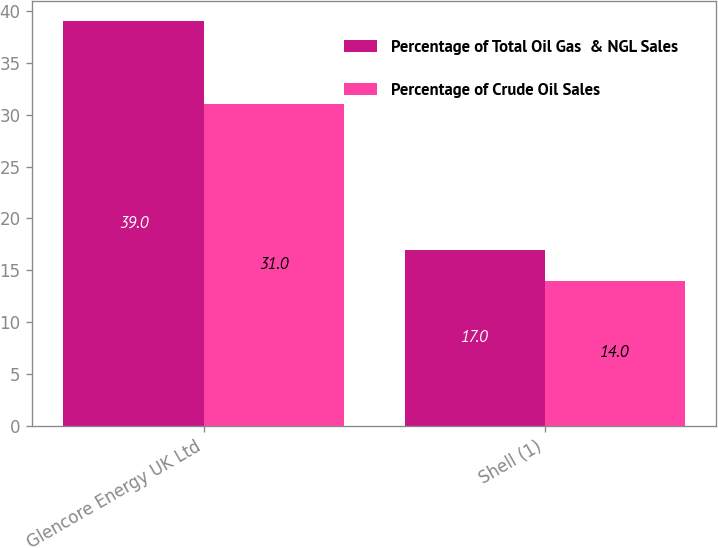<chart> <loc_0><loc_0><loc_500><loc_500><stacked_bar_chart><ecel><fcel>Glencore Energy UK Ltd<fcel>Shell (1)<nl><fcel>Percentage of Total Oil Gas  & NGL Sales<fcel>39<fcel>17<nl><fcel>Percentage of Crude Oil Sales<fcel>31<fcel>14<nl></chart> 